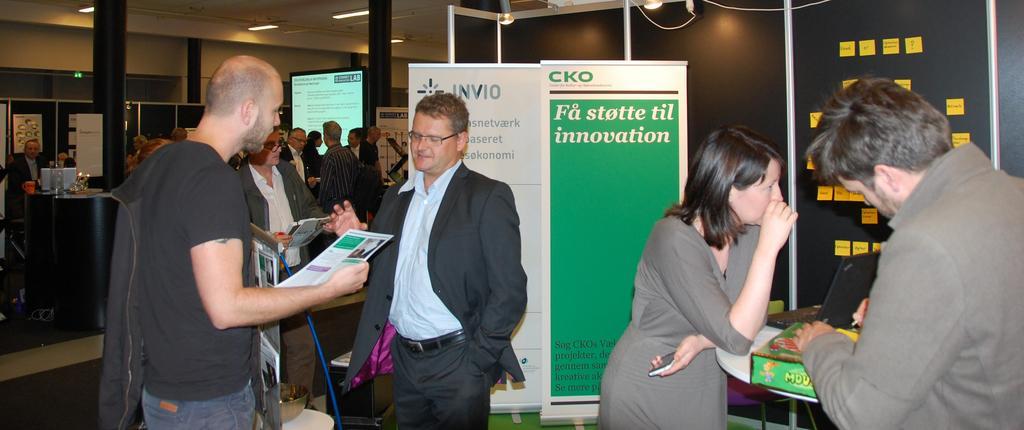How would you summarize this image in a sentence or two? In this picture I can see there is a man standing on to right and he is writing something and there is a woman standing next to him and she is looking at right side and there is a laptop in front of her. There is a man behind her and he is wearing a blazer, spectacles and he is speaking. There is a man standing in front of him holding a paper and there are many people standing in the backdrop, there are lights attached to the ceiling and there is a black wall on to left and there are paper pasted on the wall. 